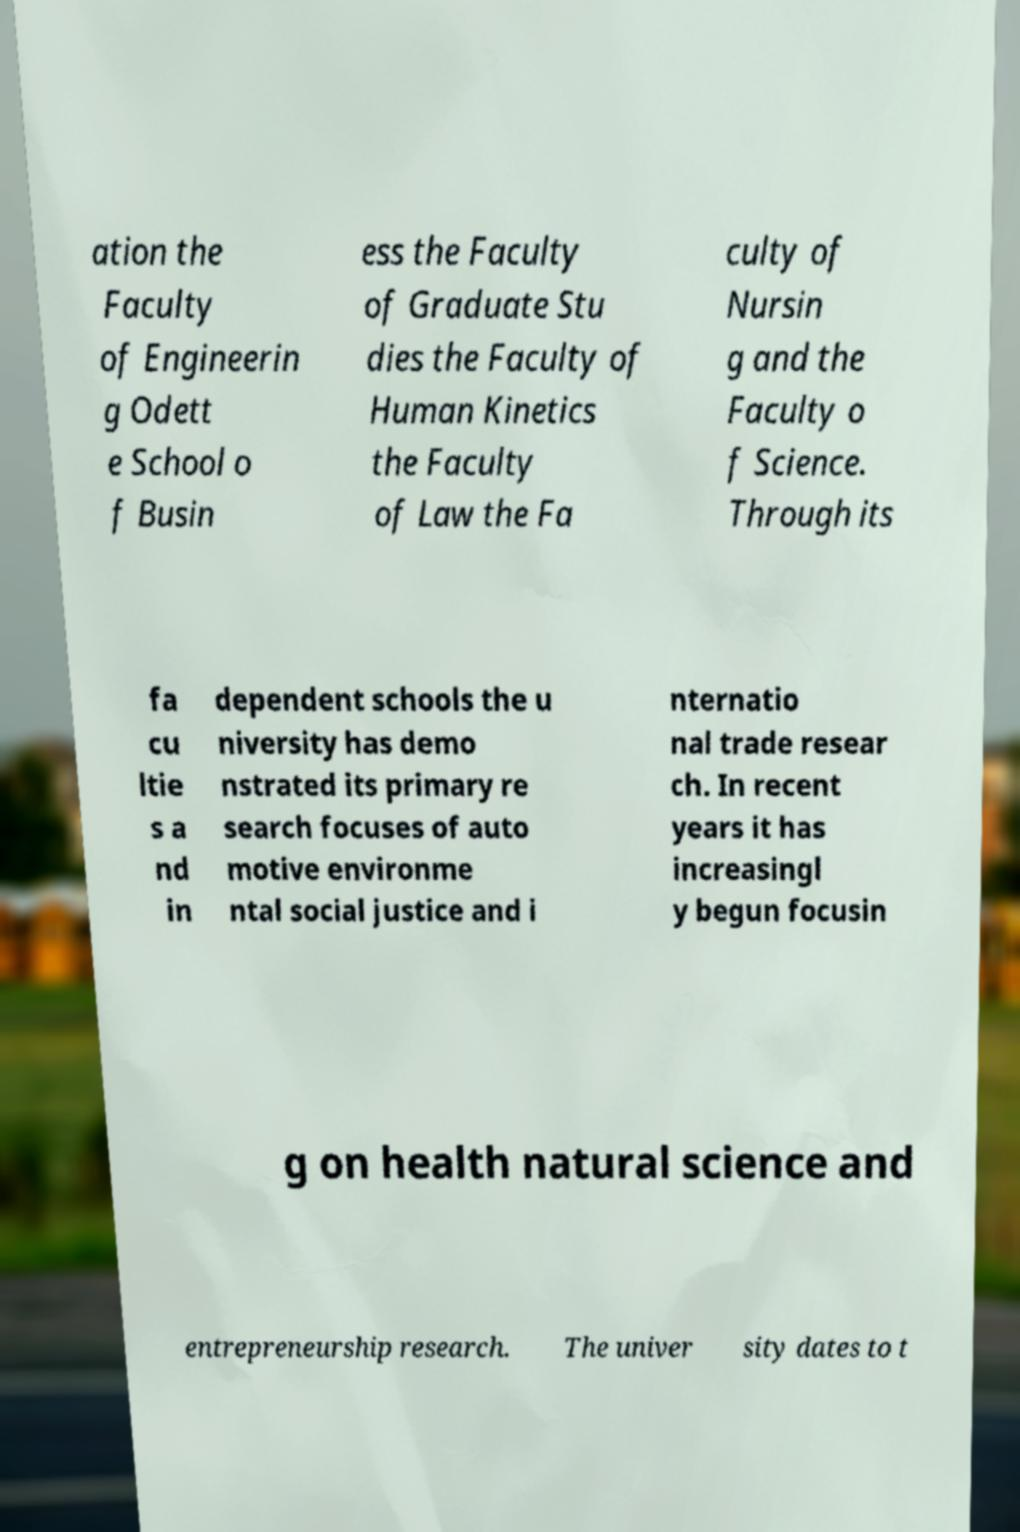Please read and relay the text visible in this image. What does it say? ation the Faculty of Engineerin g Odett e School o f Busin ess the Faculty of Graduate Stu dies the Faculty of Human Kinetics the Faculty of Law the Fa culty of Nursin g and the Faculty o f Science. Through its fa cu ltie s a nd in dependent schools the u niversity has demo nstrated its primary re search focuses of auto motive environme ntal social justice and i nternatio nal trade resear ch. In recent years it has increasingl y begun focusin g on health natural science and entrepreneurship research. The univer sity dates to t 